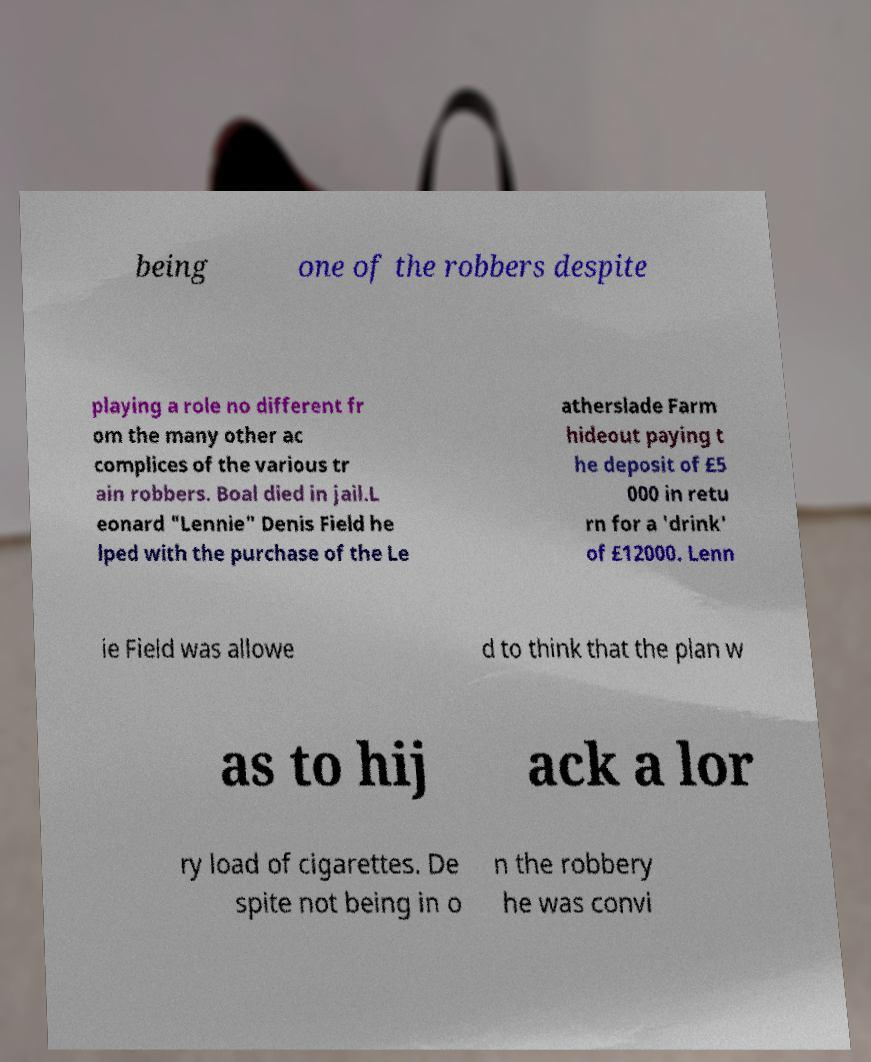Please identify and transcribe the text found in this image. being one of the robbers despite playing a role no different fr om the many other ac complices of the various tr ain robbers. Boal died in jail.L eonard "Lennie" Denis Field he lped with the purchase of the Le atherslade Farm hideout paying t he deposit of £5 000 in retu rn for a 'drink' of £12000. Lenn ie Field was allowe d to think that the plan w as to hij ack a lor ry load of cigarettes. De spite not being in o n the robbery he was convi 